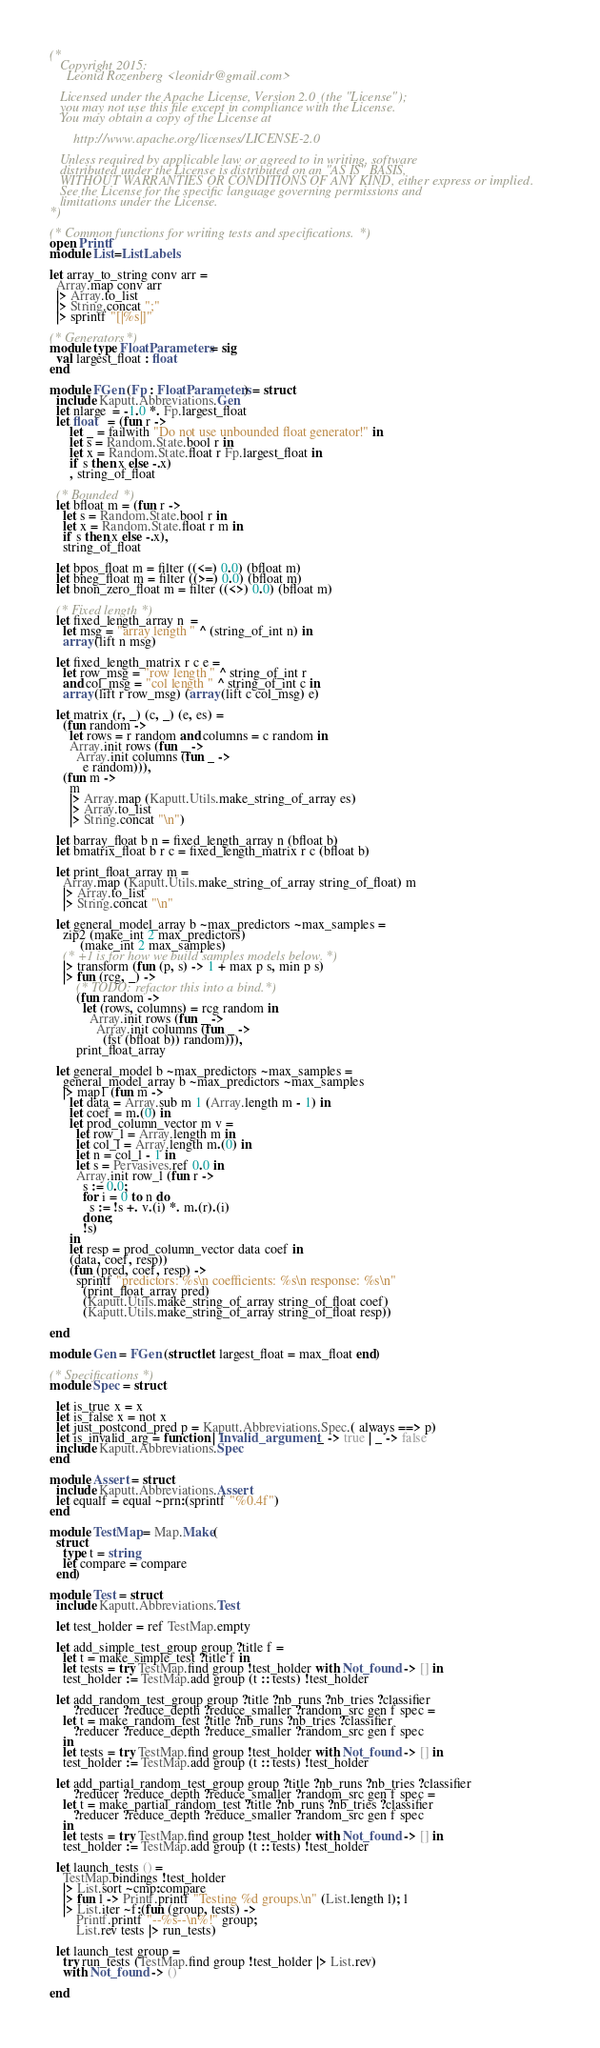<code> <loc_0><loc_0><loc_500><loc_500><_OCaml_>(*
   Copyright 2015:
     Leonid Rozenberg <leonidr@gmail.com>

   Licensed under the Apache License, Version 2.0 (the "License");
   you may not use this file except in compliance with the License.
   You may obtain a copy of the License at

       http://www.apache.org/licenses/LICENSE-2.0

   Unless required by applicable law or agreed to in writing, software
   distributed under the License is distributed on an "AS IS" BASIS,
   WITHOUT WARRANTIES OR CONDITIONS OF ANY KIND, either express or implied.
   See the License for the specific language governing permissions and
   limitations under the License.
*)

(* Common functions for writing tests and specifications. *)
open Printf
module List=ListLabels

let array_to_string conv arr =
  Array.map conv arr
  |> Array.to_list
  |> String.concat ";"
  |> sprintf "[|%s|]"

(* Generators *)
module type FloatParameters = sig
  val largest_float : float
end

module FGen (Fp : FloatParameters) = struct
  include Kaputt.Abbreviations.Gen
  let nlarge  = -1.0 *. Fp.largest_float
  let float   = (fun r ->
      let _ = failwith "Do not use unbounded float generator!" in
      let s = Random.State.bool r in
      let x = Random.State.float r Fp.largest_float in
      if s then x else -.x)
      , string_of_float

  (* Bounded *)
  let bfloat m = (fun r ->
    let s = Random.State.bool r in
    let x = Random.State.float r m in
    if s then x else -.x),
    string_of_float

  let bpos_float m = filter ((<=) 0.0) (bfloat m)
  let bneg_float m = filter ((>=) 0.0) (bfloat m)
  let bnon_zero_float m = filter ((<>) 0.0) (bfloat m)

  (* Fixed length *)
  let fixed_length_array n  =
    let msg = "array length " ^ (string_of_int n) in
    array (lift n msg)

  let fixed_length_matrix r c e =
    let row_msg = "row length " ^ string_of_int r
    and col_msg = "col length " ^ string_of_int c in
    array (lift r row_msg) (array (lift c col_msg) e)

  let matrix (r, _) (c, _) (e, es) =
    (fun random ->
      let rows = r random and columns = c random in
      Array.init rows (fun _ ->
        Array.init columns (fun _ ->
          e random))),
    (fun m ->
      m
      |> Array.map (Kaputt.Utils.make_string_of_array es)
      |> Array.to_list
      |> String.concat "\n")

  let barray_float b n = fixed_length_array n (bfloat b)
  let bmatrix_float b r c = fixed_length_matrix r c (bfloat b)

  let print_float_array m =
    Array.map (Kaputt.Utils.make_string_of_array string_of_float) m
    |> Array.to_list
    |> String.concat "\n"

  let general_model_array b ~max_predictors ~max_samples =
    zip2 (make_int 2 max_predictors)
         (make_int 2 max_samples)
    (* +1 is for how we build samples models below. *)
    |> transform (fun (p, s) -> 1 + max p s, min p s)
    |> fun (rcg, _) ->
        (* TODO: refactor this into a bind. *)
        (fun random ->
          let (rows, columns) = rcg random in
            Array.init rows (fun _ ->
              Array.init columns (fun _ ->
                (fst (bfloat b)) random))),
        print_float_array

  let general_model b ~max_predictors ~max_samples =
    general_model_array b ~max_predictors ~max_samples
    |> map1 (fun m ->
      let data = Array.sub m 1 (Array.length m - 1) in
      let coef = m.(0) in
      let prod_column_vector m v =
        let row_l = Array.length m in
        let col_l = Array.length m.(0) in
        let n = col_l - 1 in
        let s = Pervasives.ref 0.0 in
        Array.init row_l (fun r ->
          s := 0.0;
          for i = 0 to n do
            s := !s +. v.(i) *. m.(r).(i)
          done;
          !s)
      in
      let resp = prod_column_vector data coef in
      (data, coef, resp))
      (fun (pred, coef, resp) ->
        sprintf "predictors: %s\n coefficients: %s\n response: %s\n"
          (print_float_array pred)
          (Kaputt.Utils.make_string_of_array string_of_float coef)
          (Kaputt.Utils.make_string_of_array string_of_float resp))

end

module Gen = FGen (struct let largest_float = max_float end)

(* Specifications *)
module Spec = struct

  let is_true x = x
  let is_false x = not x
  let just_postcond_pred p = Kaputt.Abbreviations.Spec.( always ==> p)
  let is_invalid_arg = function | Invalid_argument _ -> true | _ -> false
  include Kaputt.Abbreviations.Spec
end

module Assert = struct
  include Kaputt.Abbreviations.Assert
  let equalf = equal ~prn:(sprintf "%0.4f")
end

module TestMap = Map.Make(
  struct
    type t = string
    let compare = compare
  end)

module Test = struct
  include Kaputt.Abbreviations.Test

  let test_holder = ref TestMap.empty

  let add_simple_test_group group ?title f =
    let t = make_simple_test ?title f in
    let tests = try TestMap.find group !test_holder with Not_found -> [] in
    test_holder := TestMap.add group (t :: tests) !test_holder

  let add_random_test_group group ?title ?nb_runs ?nb_tries ?classifier
       ?reducer ?reduce_depth ?reduce_smaller ?random_src gen f spec =
    let t = make_random_test ?title ?nb_runs ?nb_tries ?classifier
       ?reducer ?reduce_depth ?reduce_smaller ?random_src gen f spec
    in
    let tests = try TestMap.find group !test_holder with Not_found -> [] in
    test_holder := TestMap.add group (t :: tests) !test_holder

  let add_partial_random_test_group group ?title ?nb_runs ?nb_tries ?classifier
       ?reducer ?reduce_depth ?reduce_smaller ?random_src gen f spec =
    let t = make_partial_random_test ?title ?nb_runs ?nb_tries ?classifier
       ?reducer ?reduce_depth ?reduce_smaller ?random_src gen f spec
    in
    let tests = try TestMap.find group !test_holder with Not_found -> [] in
    test_holder := TestMap.add group (t :: tests) !test_holder

  let launch_tests () =
    TestMap.bindings !test_holder
    |> List.sort ~cmp:compare
    |> fun l -> Printf.printf "Testing %d groups.\n" (List.length l); l
    |> List.iter ~f:(fun (group, tests) ->
        Printf.printf "--%s--\n%!" group;
        List.rev tests |> run_tests)

  let launch_test group =
    try run_tests (TestMap.find group !test_holder |> List.rev)
    with Not_found -> ()

end
</code> 